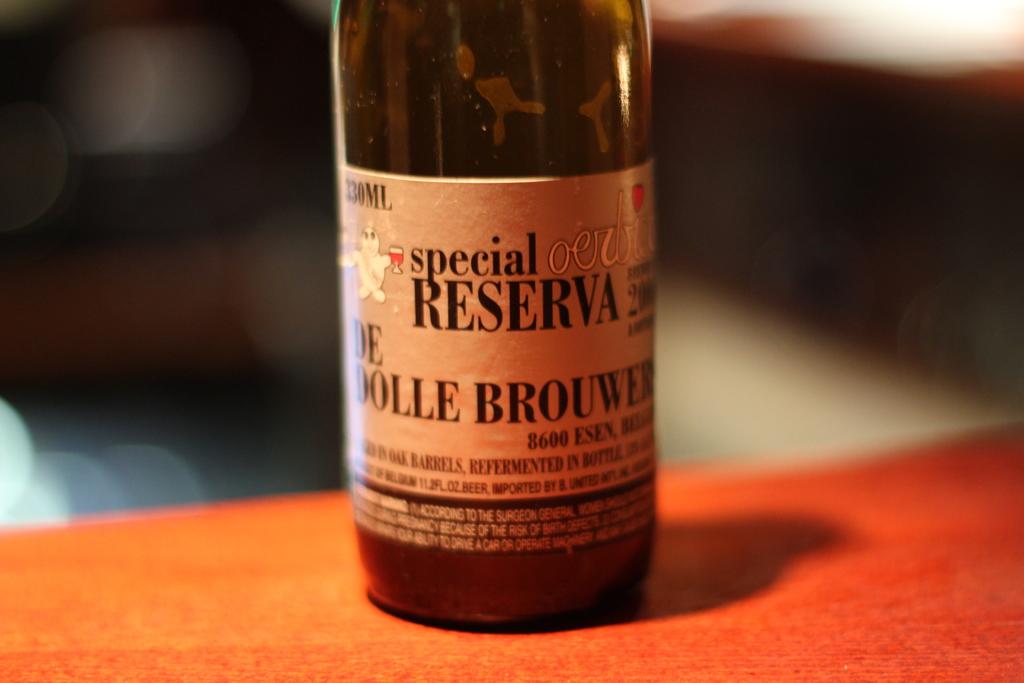Who made this special reserve?
Your response must be concise. De dolle brouwer. How many ml are in the bottle?
Keep it short and to the point. 330. 